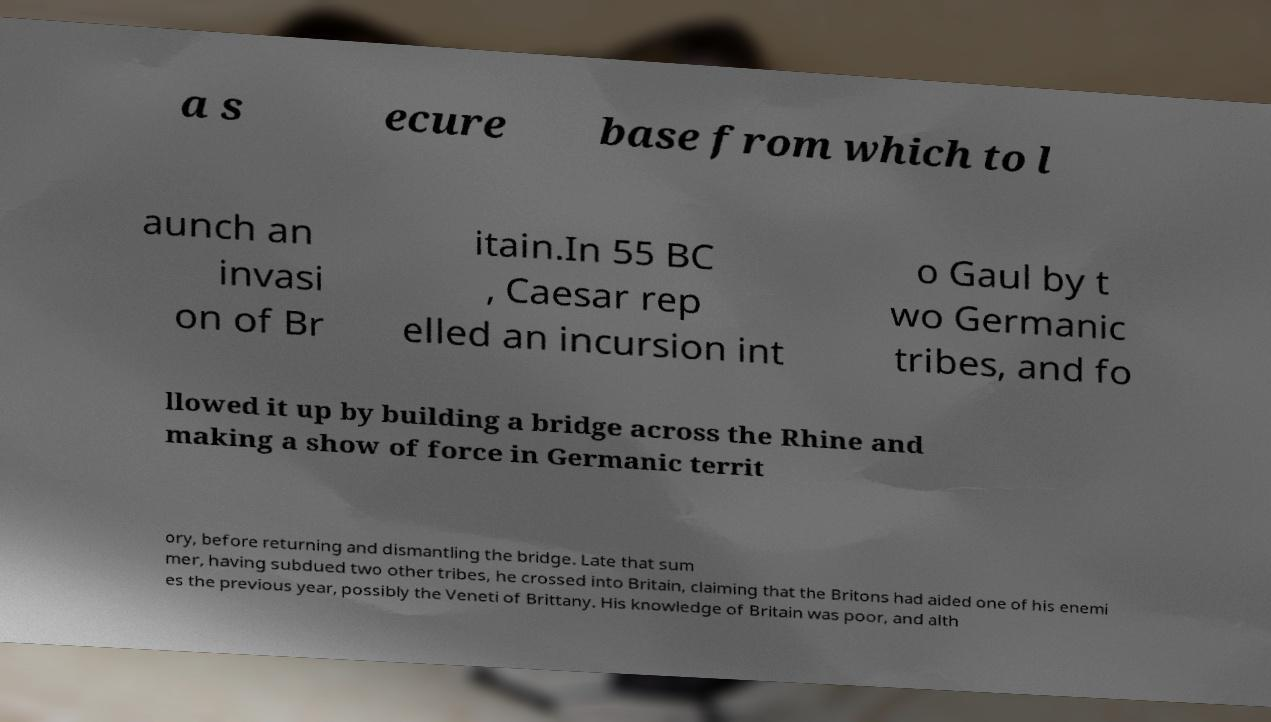Please read and relay the text visible in this image. What does it say? a s ecure base from which to l aunch an invasi on of Br itain.In 55 BC , Caesar rep elled an incursion int o Gaul by t wo Germanic tribes, and fo llowed it up by building a bridge across the Rhine and making a show of force in Germanic territ ory, before returning and dismantling the bridge. Late that sum mer, having subdued two other tribes, he crossed into Britain, claiming that the Britons had aided one of his enemi es the previous year, possibly the Veneti of Brittany. His knowledge of Britain was poor, and alth 